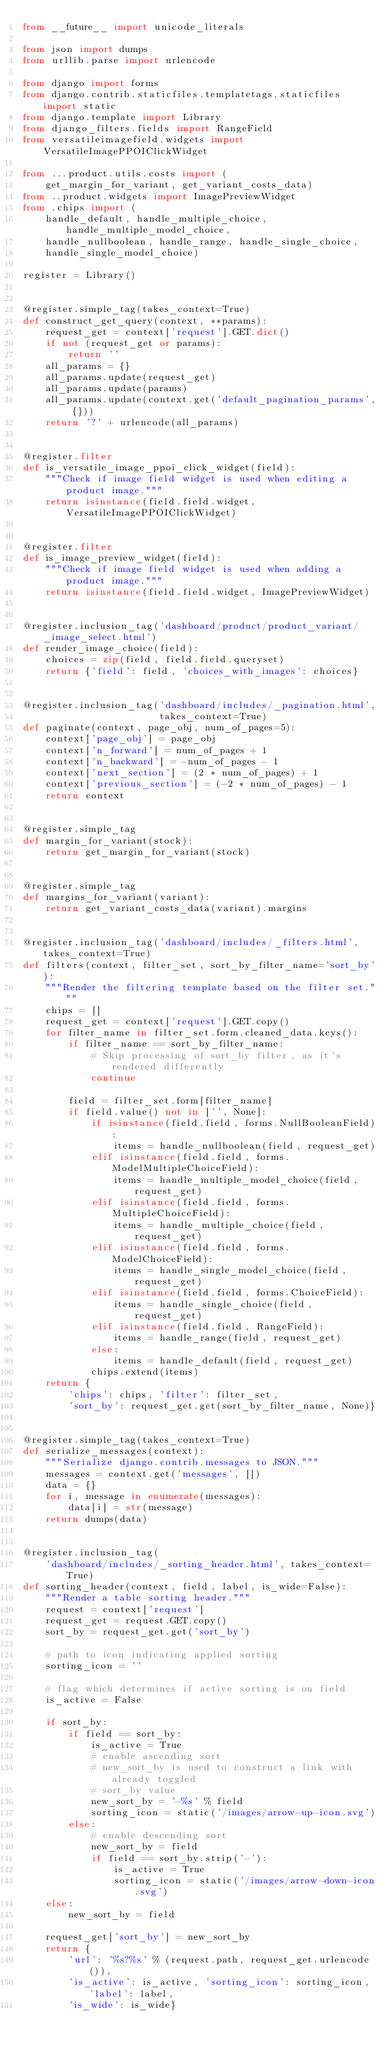<code> <loc_0><loc_0><loc_500><loc_500><_Python_>from __future__ import unicode_literals

from json import dumps
from urllib.parse import urlencode

from django import forms
from django.contrib.staticfiles.templatetags.staticfiles import static
from django.template import Library
from django_filters.fields import RangeField
from versatileimagefield.widgets import VersatileImagePPOIClickWidget

from ...product.utils.costs import (
    get_margin_for_variant, get_variant_costs_data)
from ..product.widgets import ImagePreviewWidget
from .chips import (
    handle_default, handle_multiple_choice, handle_multiple_model_choice,
    handle_nullboolean, handle_range, handle_single_choice,
    handle_single_model_choice)

register = Library()


@register.simple_tag(takes_context=True)
def construct_get_query(context, **params):
    request_get = context['request'].GET.dict()
    if not (request_get or params):
        return ''
    all_params = {}
    all_params.update(request_get)
    all_params.update(params)
    all_params.update(context.get('default_pagination_params', {}))
    return '?' + urlencode(all_params)


@register.filter
def is_versatile_image_ppoi_click_widget(field):
    """Check if image field widget is used when editing a product image."""
    return isinstance(field.field.widget, VersatileImagePPOIClickWidget)


@register.filter
def is_image_preview_widget(field):
    """Check if image field widget is used when adding a product image."""
    return isinstance(field.field.widget, ImagePreviewWidget)


@register.inclusion_tag('dashboard/product/product_variant/_image_select.html')
def render_image_choice(field):
    choices = zip(field, field.field.queryset)
    return {'field': field, 'choices_with_images': choices}


@register.inclusion_tag('dashboard/includes/_pagination.html',
                        takes_context=True)
def paginate(context, page_obj, num_of_pages=5):
    context['page_obj'] = page_obj
    context['n_forward'] = num_of_pages + 1
    context['n_backward'] = -num_of_pages - 1
    context['next_section'] = (2 * num_of_pages) + 1
    context['previous_section'] = (-2 * num_of_pages) - 1
    return context


@register.simple_tag
def margin_for_variant(stock):
    return get_margin_for_variant(stock)


@register.simple_tag
def margins_for_variant(variant):
    return get_variant_costs_data(variant).margins


@register.inclusion_tag('dashboard/includes/_filters.html', takes_context=True)
def filters(context, filter_set, sort_by_filter_name='sort_by'):
    """Render the filtering template based on the filter set."""
    chips = []
    request_get = context['request'].GET.copy()
    for filter_name in filter_set.form.cleaned_data.keys():
        if filter_name == sort_by_filter_name:
            # Skip processing of sort_by filter, as it's rendered differently
            continue

        field = filter_set.form[filter_name]
        if field.value() not in ['', None]:
            if isinstance(field.field, forms.NullBooleanField):
                items = handle_nullboolean(field, request_get)
            elif isinstance(field.field, forms.ModelMultipleChoiceField):
                items = handle_multiple_model_choice(field, request_get)
            elif isinstance(field.field, forms.MultipleChoiceField):
                items = handle_multiple_choice(field, request_get)
            elif isinstance(field.field, forms.ModelChoiceField):
                items = handle_single_model_choice(field, request_get)
            elif isinstance(field.field, forms.ChoiceField):
                items = handle_single_choice(field, request_get)
            elif isinstance(field.field, RangeField):
                items = handle_range(field, request_get)
            else:
                items = handle_default(field, request_get)
            chips.extend(items)
    return {
        'chips': chips, 'filter': filter_set,
        'sort_by': request_get.get(sort_by_filter_name, None)}


@register.simple_tag(takes_context=True)
def serialize_messages(context):
    """Serialize django.contrib.messages to JSON."""
    messages = context.get('messages', [])
    data = {}
    for i, message in enumerate(messages):
        data[i] = str(message)
    return dumps(data)


@register.inclusion_tag(
    'dashboard/includes/_sorting_header.html', takes_context=True)
def sorting_header(context, field, label, is_wide=False):
    """Render a table sorting header."""
    request = context['request']
    request_get = request.GET.copy()
    sort_by = request_get.get('sort_by')

    # path to icon indicating applied sorting
    sorting_icon = ''

    # flag which determines if active sorting is on field
    is_active = False

    if sort_by:
        if field == sort_by:
            is_active = True
            # enable ascending sort
            # new_sort_by is used to construct a link with already toggled
            # sort_by value
            new_sort_by = '-%s' % field
            sorting_icon = static('/images/arrow-up-icon.svg')
        else:
            # enable descending sort
            new_sort_by = field
            if field == sort_by.strip('-'):
                is_active = True
                sorting_icon = static('/images/arrow-down-icon.svg')
    else:
        new_sort_by = field

    request_get['sort_by'] = new_sort_by
    return {
        'url': '%s?%s' % (request.path, request_get.urlencode()),
        'is_active': is_active, 'sorting_icon': sorting_icon, 'label': label,
        'is_wide': is_wide}
</code> 